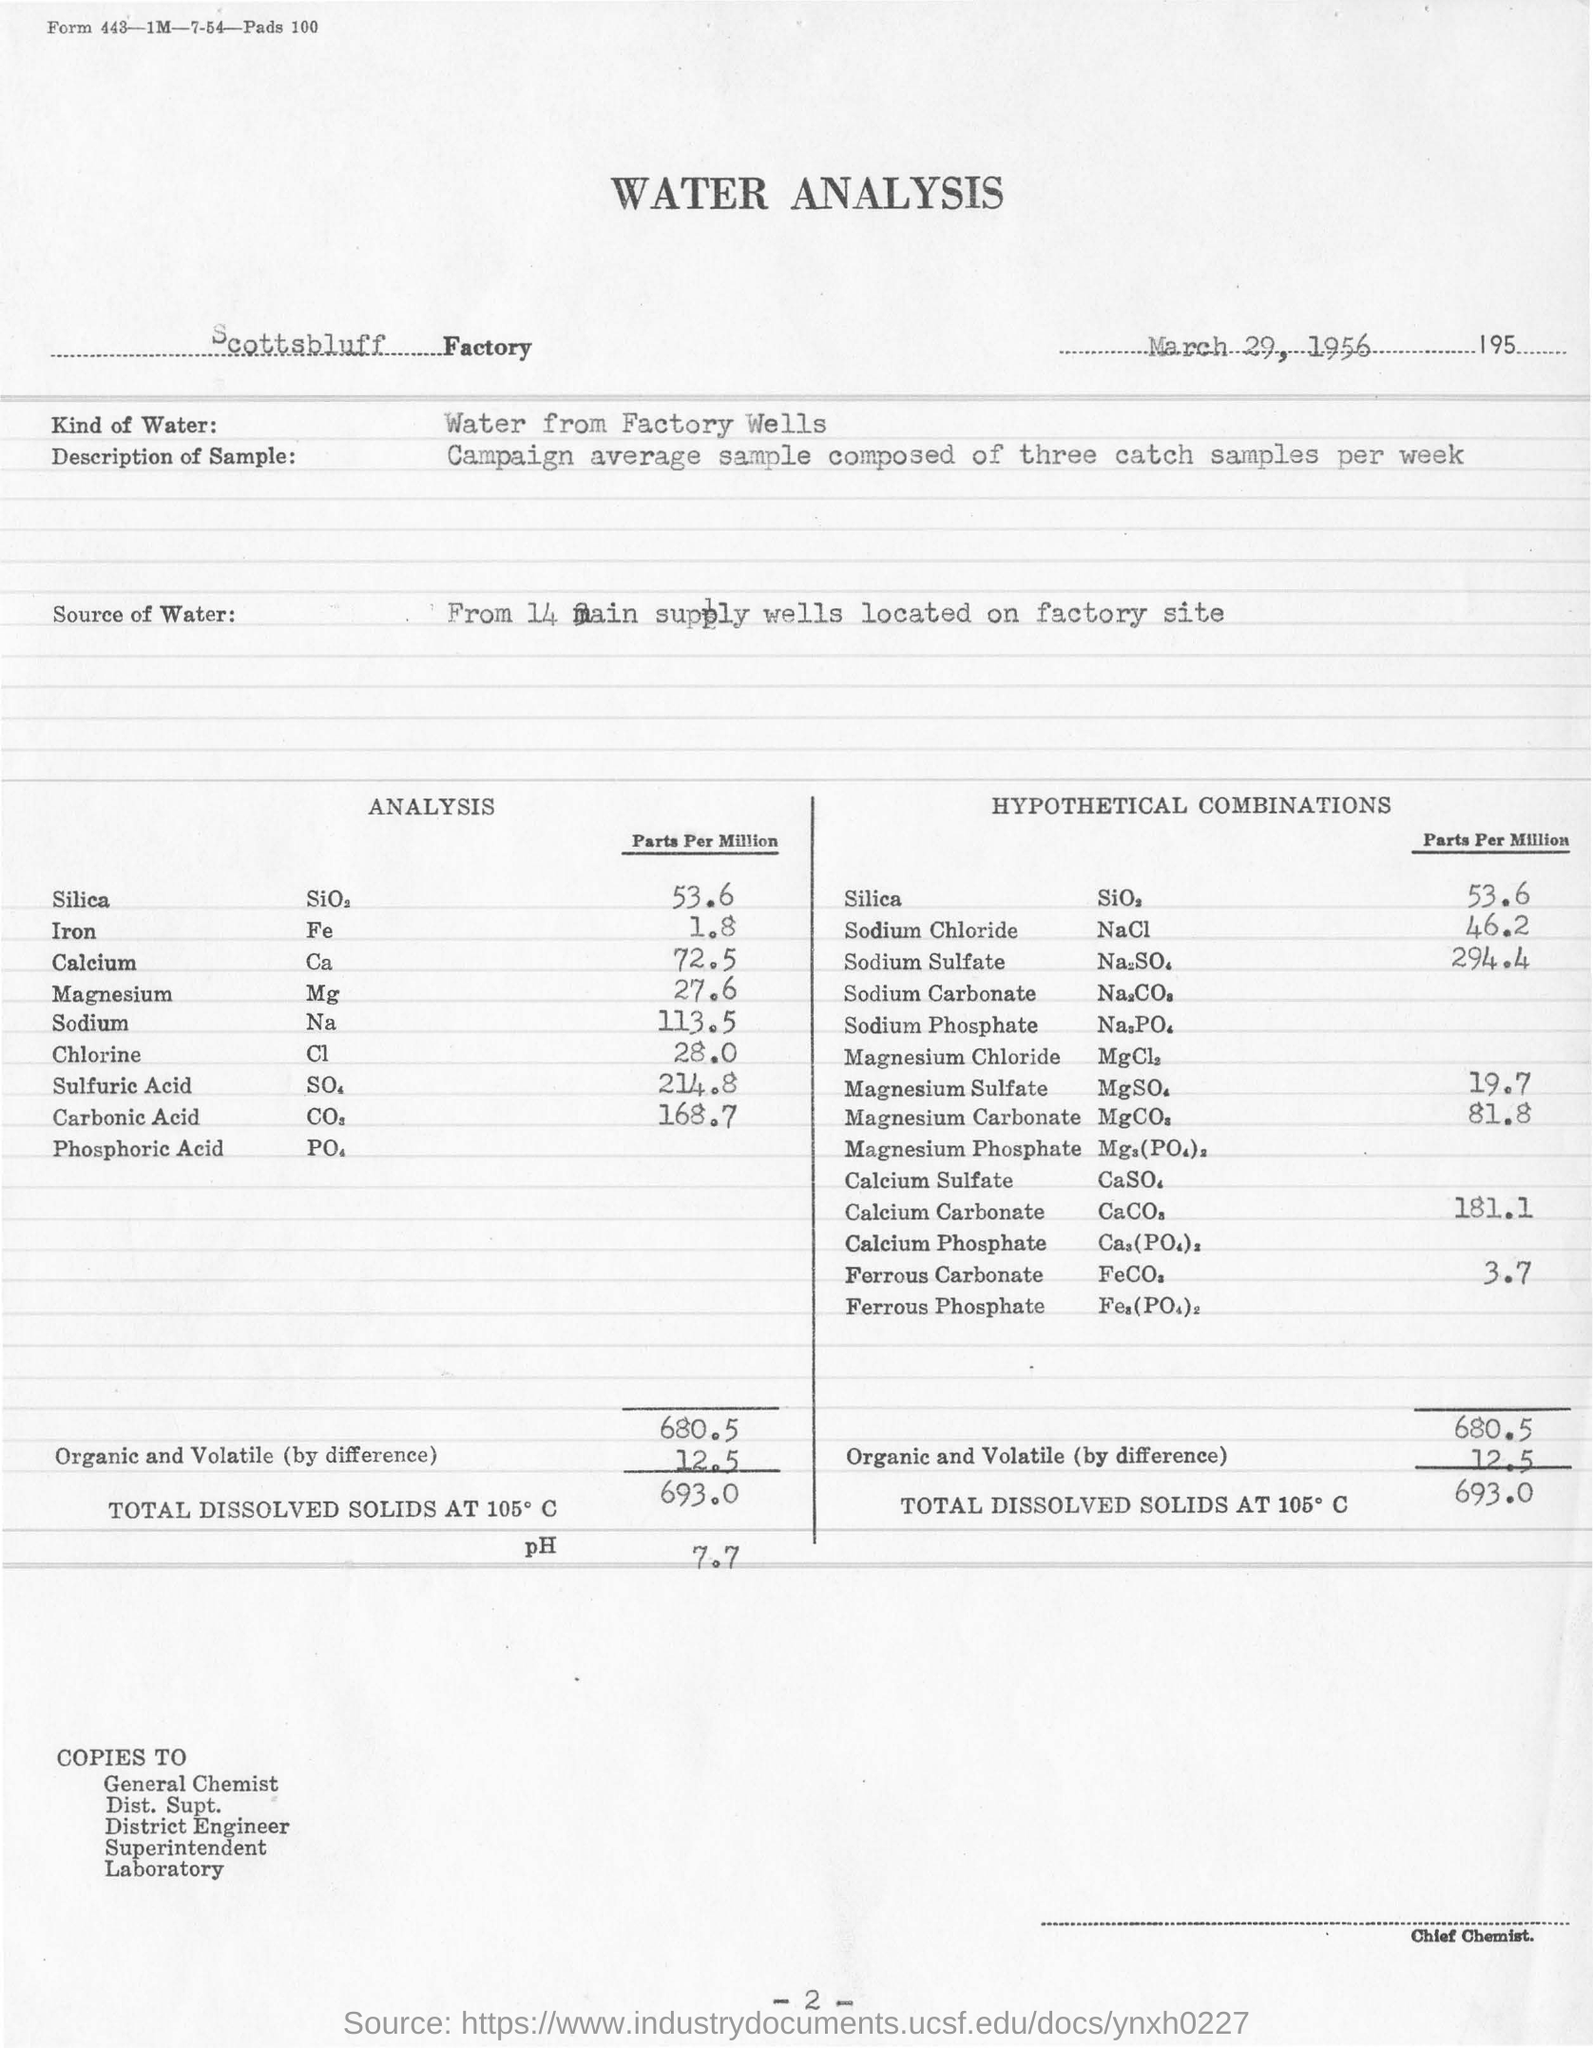Identify some key points in this picture. The parts per million analysis for iron is 1.8. The water analysis is conducted at the Scottsbluff Factory. The chemical formula for chlorine is Cl. The parts per million (ppm) analysis for silica is 536. The chemical formula for sodium is Na. 